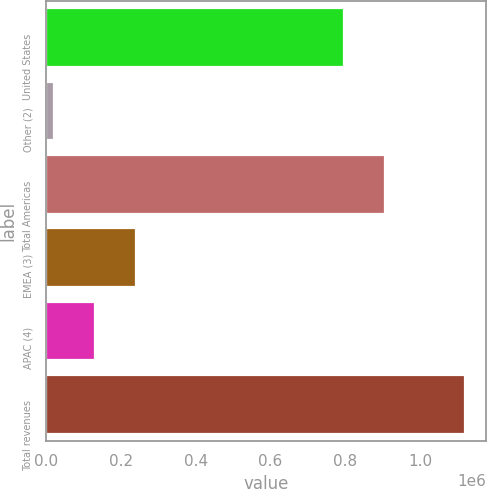<chart> <loc_0><loc_0><loc_500><loc_500><bar_chart><fcel>United States<fcel>Other (2)<fcel>Total Americas<fcel>EMEA (3)<fcel>APAC (4)<fcel>Total revenues<nl><fcel>796124<fcel>19734<fcel>906210<fcel>239906<fcel>129820<fcel>1.1206e+06<nl></chart> 